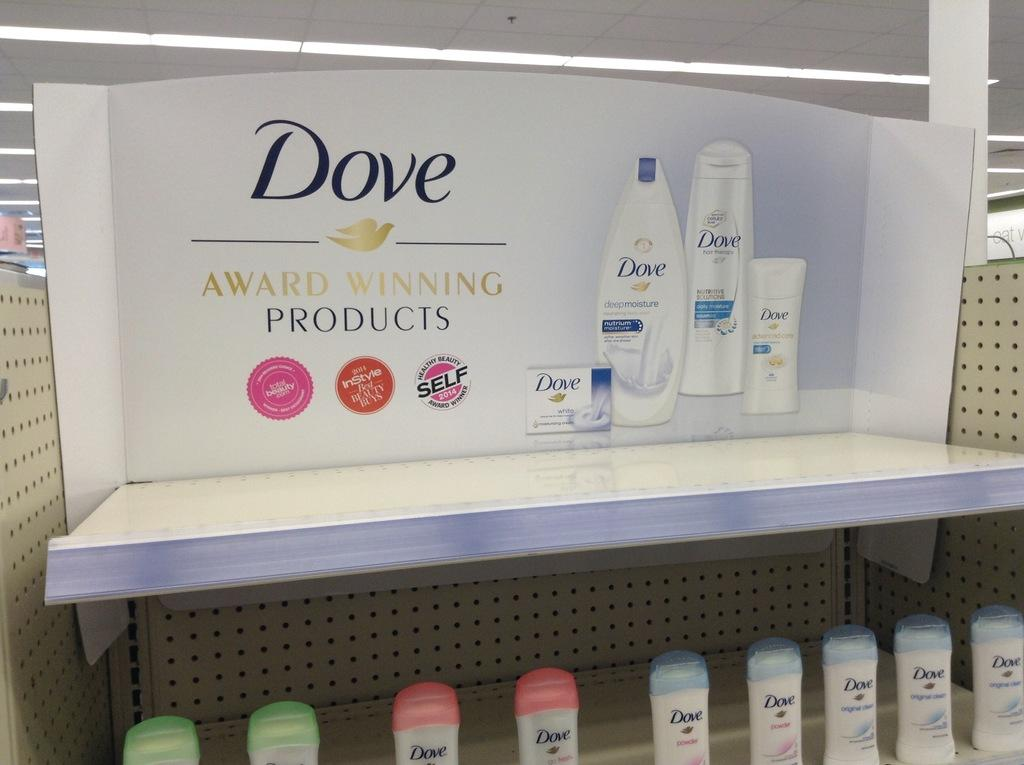Provide a one-sentence caption for the provided image. a display case for Dove Award Winning Products in a store. 